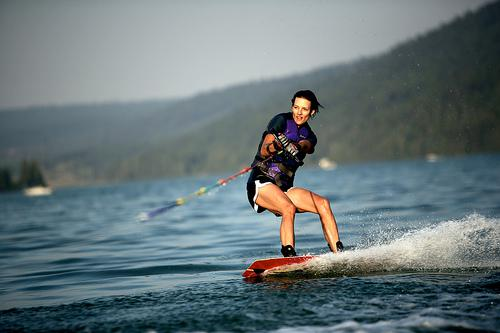Question: how many fish are visible?
Choices:
A. 1.
B. 2.
C. 0.
D. 3.
Answer with the letter. Answer: C Question: what color is the woman's outfit?
Choices:
A. Black and purple.
B. Black and white.
C. Black and blue.
D. White and purple.
Answer with the letter. Answer: A 